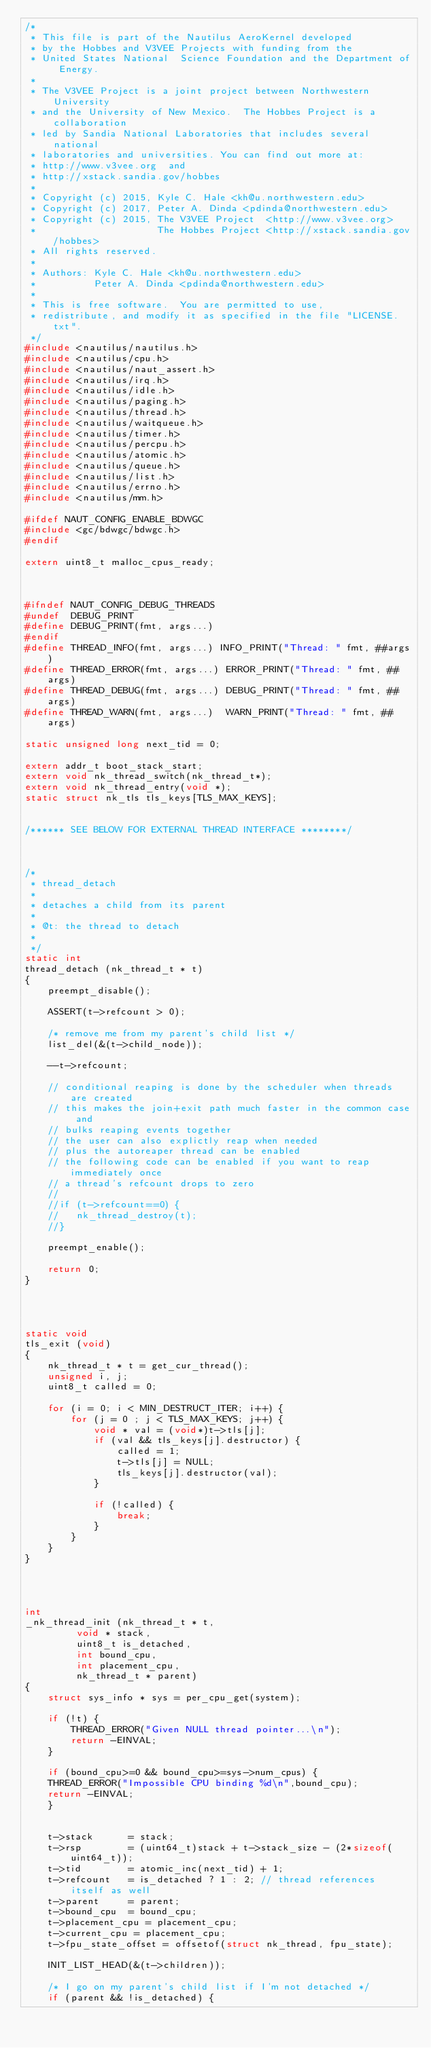<code> <loc_0><loc_0><loc_500><loc_500><_C_>/* 
 * This file is part of the Nautilus AeroKernel developed
 * by the Hobbes and V3VEE Projects with funding from the 
 * United States National  Science Foundation and the Department of Energy.  
 *
 * The V3VEE Project is a joint project between Northwestern University
 * and the University of New Mexico.  The Hobbes Project is a collaboration
 * led by Sandia National Laboratories that includes several national 
 * laboratories and universities. You can find out more at:
 * http://www.v3vee.org  and
 * http://xstack.sandia.gov/hobbes
 *
 * Copyright (c) 2015, Kyle C. Hale <kh@u.northwestern.edu>
 * Copyright (c) 2017, Peter A. Dinda <pdinda@northwestern.edu>
 * Copyright (c) 2015, The V3VEE Project  <http://www.v3vee.org> 
 *                     The Hobbes Project <http://xstack.sandia.gov/hobbes>
 * All rights reserved.
 *
 * Authors: Kyle C. Hale <kh@u.northwestern.edu>
 *          Peter A. Dinda <pdinda@northwestern.edu>
 *
 * This is free software.  You are permitted to use,
 * redistribute, and modify it as specified in the file "LICENSE.txt".
 */
#include <nautilus/nautilus.h>
#include <nautilus/cpu.h>
#include <nautilus/naut_assert.h>
#include <nautilus/irq.h>
#include <nautilus/idle.h>
#include <nautilus/paging.h>
#include <nautilus/thread.h>
#include <nautilus/waitqueue.h>
#include <nautilus/timer.h>
#include <nautilus/percpu.h>
#include <nautilus/atomic.h>
#include <nautilus/queue.h>
#include <nautilus/list.h>
#include <nautilus/errno.h>
#include <nautilus/mm.h>

#ifdef NAUT_CONFIG_ENABLE_BDWGC
#include <gc/bdwgc/bdwgc.h>
#endif

extern uint8_t malloc_cpus_ready;



#ifndef NAUT_CONFIG_DEBUG_THREADS
#undef  DEBUG_PRINT
#define DEBUG_PRINT(fmt, args...)
#endif
#define THREAD_INFO(fmt, args...) INFO_PRINT("Thread: " fmt, ##args)
#define THREAD_ERROR(fmt, args...) ERROR_PRINT("Thread: " fmt, ##args)
#define THREAD_DEBUG(fmt, args...) DEBUG_PRINT("Thread: " fmt, ##args)
#define THREAD_WARN(fmt, args...)  WARN_PRINT("Thread: " fmt, ##args)

static unsigned long next_tid = 0;

extern addr_t boot_stack_start;
extern void nk_thread_switch(nk_thread_t*);
extern void nk_thread_entry(void *);
static struct nk_tls tls_keys[TLS_MAX_KEYS];


/****** SEE BELOW FOR EXTERNAL THREAD INTERFACE ********/



/*
 * thread_detach
 *
 * detaches a child from its parent
 *
 * @t: the thread to detach
 *
 */
static int
thread_detach (nk_thread_t * t)
{
    preempt_disable();

    ASSERT(t->refcount > 0);

    /* remove me from my parent's child list */
    list_del(&(t->child_node));

    --t->refcount;

    // conditional reaping is done by the scheduler when threads are created
    // this makes the join+exit path much faster in the common case and 
    // bulks reaping events together
    // the user can also explictly reap when needed
    // plus the autoreaper thread can be enabled 
    // the following code can be enabled if you want to reap immediately once
    // a thread's refcount drops to zero
    // 
    //if (t->refcount==0) { 
    //   nk_thread_destroy(t);
    //}

    preempt_enable();

    return 0;
}




static void 
tls_exit (void) 
{
    nk_thread_t * t = get_cur_thread();
    unsigned i, j;
    uint8_t called = 0;

    for (i = 0; i < MIN_DESTRUCT_ITER; i++) {
        for (j = 0 ; j < TLS_MAX_KEYS; j++) {
            void * val = (void*)t->tls[j]; 
            if (val && tls_keys[j].destructor) {
                called = 1;
                t->tls[j] = NULL;
                tls_keys[j].destructor(val);
            }

            if (!called) {
                break;
            }
        }
    }
}




int
_nk_thread_init (nk_thread_t * t, 
		 void * stack, 
		 uint8_t is_detached, 
		 int bound_cpu, 
		 int placement_cpu,
		 nk_thread_t * parent)
{
    struct sys_info * sys = per_cpu_get(system);

    if (!t) {
        THREAD_ERROR("Given NULL thread pointer...\n");
        return -EINVAL;
    }

    if (bound_cpu>=0 && bound_cpu>=sys->num_cpus) {
	THREAD_ERROR("Impossible CPU binding %d\n",bound_cpu);
	return -EINVAL;
    }


    t->stack      = stack;
    t->rsp        = (uint64_t)stack + t->stack_size - (2*sizeof(uint64_t));
    t->tid        = atomic_inc(next_tid) + 1;
    t->refcount   = is_detached ? 1 : 2; // thread references itself as well
    t->parent     = parent;
    t->bound_cpu  = bound_cpu;
    t->placement_cpu = placement_cpu;
    t->current_cpu = placement_cpu;
    t->fpu_state_offset = offsetof(struct nk_thread, fpu_state);

    INIT_LIST_HEAD(&(t->children));

    /* I go on my parent's child list if I'm not detached */
    if (parent && !is_detached) {</code> 